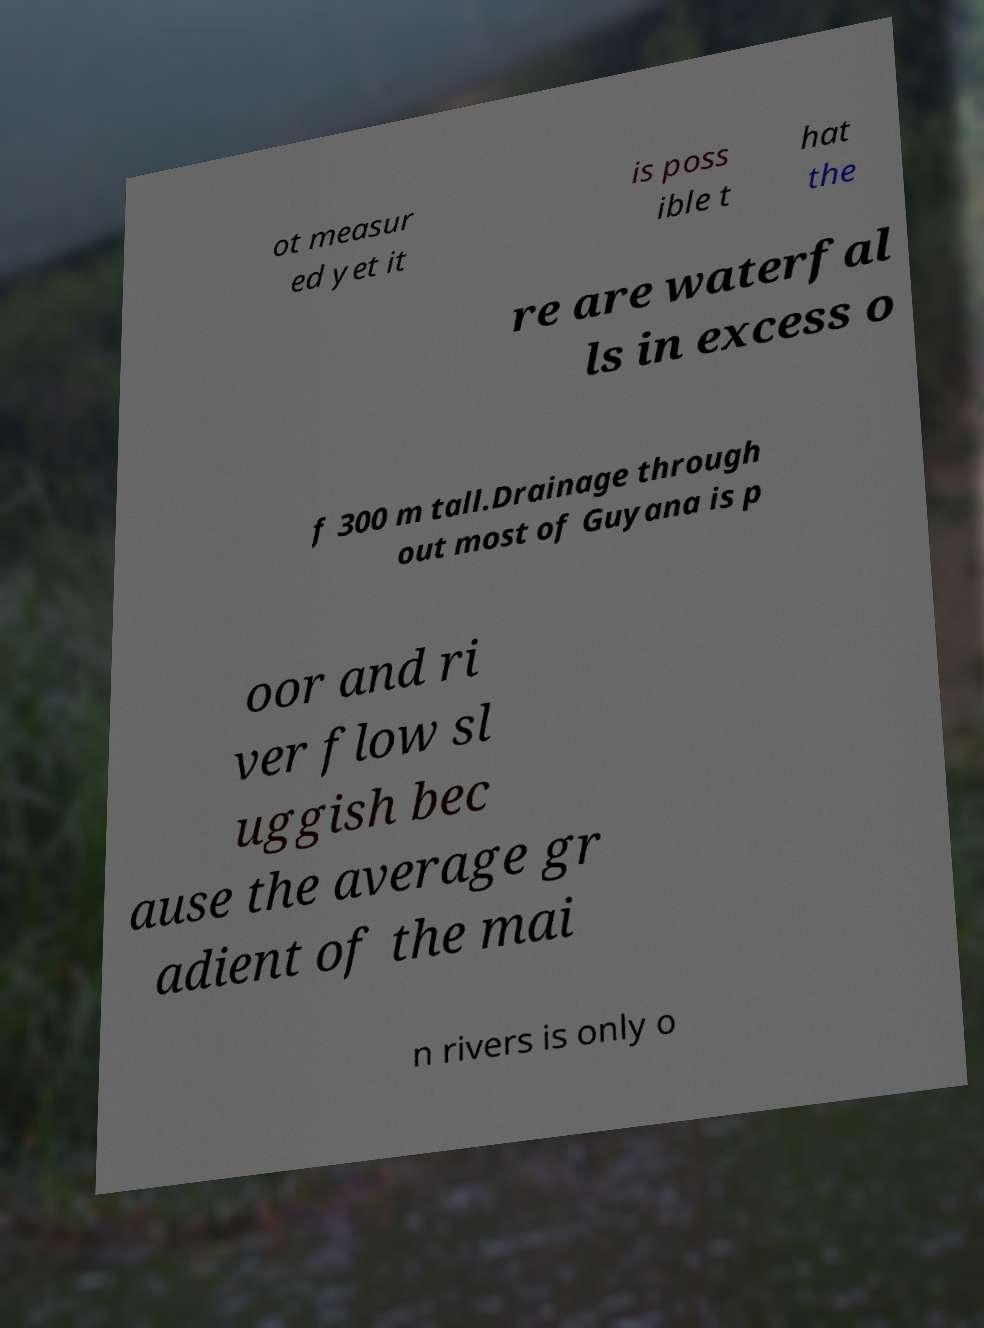Can you accurately transcribe the text from the provided image for me? ot measur ed yet it is poss ible t hat the re are waterfal ls in excess o f 300 m tall.Drainage through out most of Guyana is p oor and ri ver flow sl uggish bec ause the average gr adient of the mai n rivers is only o 